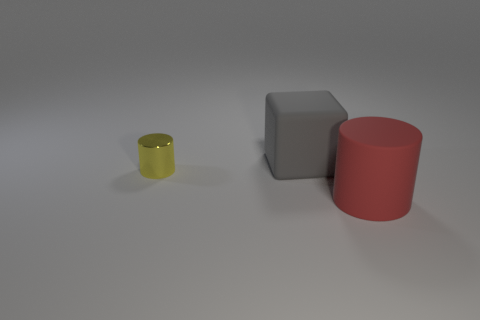Add 2 blue metallic cylinders. How many objects exist? 5 Subtract all cylinders. How many objects are left? 1 Subtract all large red matte cylinders. Subtract all big cubes. How many objects are left? 1 Add 2 metal things. How many metal things are left? 3 Add 1 tiny cylinders. How many tiny cylinders exist? 2 Subtract 0 purple blocks. How many objects are left? 3 